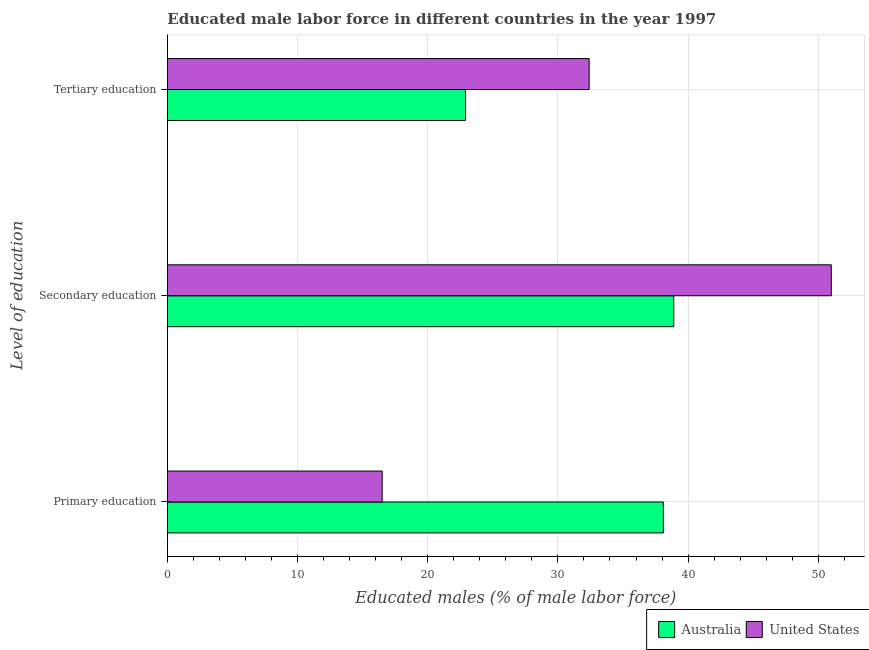How many different coloured bars are there?
Your answer should be compact. 2. Are the number of bars per tick equal to the number of legend labels?
Keep it short and to the point. Yes. What is the label of the 1st group of bars from the top?
Make the answer very short. Tertiary education. What is the percentage of male labor force who received primary education in United States?
Provide a short and direct response. 16.5. Across all countries, what is the minimum percentage of male labor force who received secondary education?
Ensure brevity in your answer.  38.9. In which country was the percentage of male labor force who received tertiary education minimum?
Make the answer very short. Australia. What is the total percentage of male labor force who received primary education in the graph?
Offer a very short reply. 54.6. What is the difference between the percentage of male labor force who received primary education in Australia and that in United States?
Give a very brief answer. 21.6. What is the difference between the percentage of male labor force who received secondary education in Australia and the percentage of male labor force who received tertiary education in United States?
Make the answer very short. 6.5. What is the average percentage of male labor force who received tertiary education per country?
Ensure brevity in your answer.  27.65. What is the difference between the percentage of male labor force who received tertiary education and percentage of male labor force who received secondary education in United States?
Your answer should be compact. -18.6. In how many countries, is the percentage of male labor force who received tertiary education greater than 48 %?
Provide a short and direct response. 0. What is the ratio of the percentage of male labor force who received secondary education in United States to that in Australia?
Provide a short and direct response. 1.31. Is the percentage of male labor force who received secondary education in United States less than that in Australia?
Keep it short and to the point. No. What is the difference between the highest and the second highest percentage of male labor force who received primary education?
Keep it short and to the point. 21.6. What is the difference between the highest and the lowest percentage of male labor force who received primary education?
Offer a very short reply. 21.6. In how many countries, is the percentage of male labor force who received primary education greater than the average percentage of male labor force who received primary education taken over all countries?
Your response must be concise. 1. What does the 2nd bar from the top in Tertiary education represents?
Your response must be concise. Australia. What is the difference between two consecutive major ticks on the X-axis?
Offer a terse response. 10. Does the graph contain grids?
Give a very brief answer. Yes. What is the title of the graph?
Your response must be concise. Educated male labor force in different countries in the year 1997. What is the label or title of the X-axis?
Provide a short and direct response. Educated males (% of male labor force). What is the label or title of the Y-axis?
Offer a terse response. Level of education. What is the Educated males (% of male labor force) in Australia in Primary education?
Your answer should be very brief. 38.1. What is the Educated males (% of male labor force) in Australia in Secondary education?
Offer a very short reply. 38.9. What is the Educated males (% of male labor force) of United States in Secondary education?
Keep it short and to the point. 51. What is the Educated males (% of male labor force) of Australia in Tertiary education?
Offer a very short reply. 22.9. What is the Educated males (% of male labor force) in United States in Tertiary education?
Keep it short and to the point. 32.4. Across all Level of education, what is the maximum Educated males (% of male labor force) of Australia?
Make the answer very short. 38.9. Across all Level of education, what is the maximum Educated males (% of male labor force) in United States?
Ensure brevity in your answer.  51. Across all Level of education, what is the minimum Educated males (% of male labor force) in Australia?
Your response must be concise. 22.9. Across all Level of education, what is the minimum Educated males (% of male labor force) in United States?
Offer a terse response. 16.5. What is the total Educated males (% of male labor force) of Australia in the graph?
Your answer should be compact. 99.9. What is the total Educated males (% of male labor force) in United States in the graph?
Keep it short and to the point. 99.9. What is the difference between the Educated males (% of male labor force) of Australia in Primary education and that in Secondary education?
Your response must be concise. -0.8. What is the difference between the Educated males (% of male labor force) of United States in Primary education and that in Secondary education?
Provide a succinct answer. -34.5. What is the difference between the Educated males (% of male labor force) in Australia in Primary education and that in Tertiary education?
Your answer should be very brief. 15.2. What is the difference between the Educated males (% of male labor force) of United States in Primary education and that in Tertiary education?
Ensure brevity in your answer.  -15.9. What is the difference between the Educated males (% of male labor force) of Australia in Secondary education and that in Tertiary education?
Provide a short and direct response. 16. What is the difference between the Educated males (% of male labor force) in United States in Secondary education and that in Tertiary education?
Make the answer very short. 18.6. What is the difference between the Educated males (% of male labor force) of Australia in Primary education and the Educated males (% of male labor force) of United States in Tertiary education?
Offer a very short reply. 5.7. What is the average Educated males (% of male labor force) in Australia per Level of education?
Make the answer very short. 33.3. What is the average Educated males (% of male labor force) in United States per Level of education?
Offer a very short reply. 33.3. What is the difference between the Educated males (% of male labor force) in Australia and Educated males (% of male labor force) in United States in Primary education?
Your answer should be compact. 21.6. What is the difference between the Educated males (% of male labor force) in Australia and Educated males (% of male labor force) in United States in Secondary education?
Your answer should be very brief. -12.1. What is the difference between the Educated males (% of male labor force) in Australia and Educated males (% of male labor force) in United States in Tertiary education?
Offer a very short reply. -9.5. What is the ratio of the Educated males (% of male labor force) of Australia in Primary education to that in Secondary education?
Ensure brevity in your answer.  0.98. What is the ratio of the Educated males (% of male labor force) in United States in Primary education to that in Secondary education?
Provide a short and direct response. 0.32. What is the ratio of the Educated males (% of male labor force) of Australia in Primary education to that in Tertiary education?
Offer a terse response. 1.66. What is the ratio of the Educated males (% of male labor force) of United States in Primary education to that in Tertiary education?
Your answer should be compact. 0.51. What is the ratio of the Educated males (% of male labor force) of Australia in Secondary education to that in Tertiary education?
Make the answer very short. 1.7. What is the ratio of the Educated males (% of male labor force) of United States in Secondary education to that in Tertiary education?
Make the answer very short. 1.57. What is the difference between the highest and the second highest Educated males (% of male labor force) in United States?
Ensure brevity in your answer.  18.6. What is the difference between the highest and the lowest Educated males (% of male labor force) of Australia?
Provide a short and direct response. 16. What is the difference between the highest and the lowest Educated males (% of male labor force) in United States?
Your answer should be very brief. 34.5. 